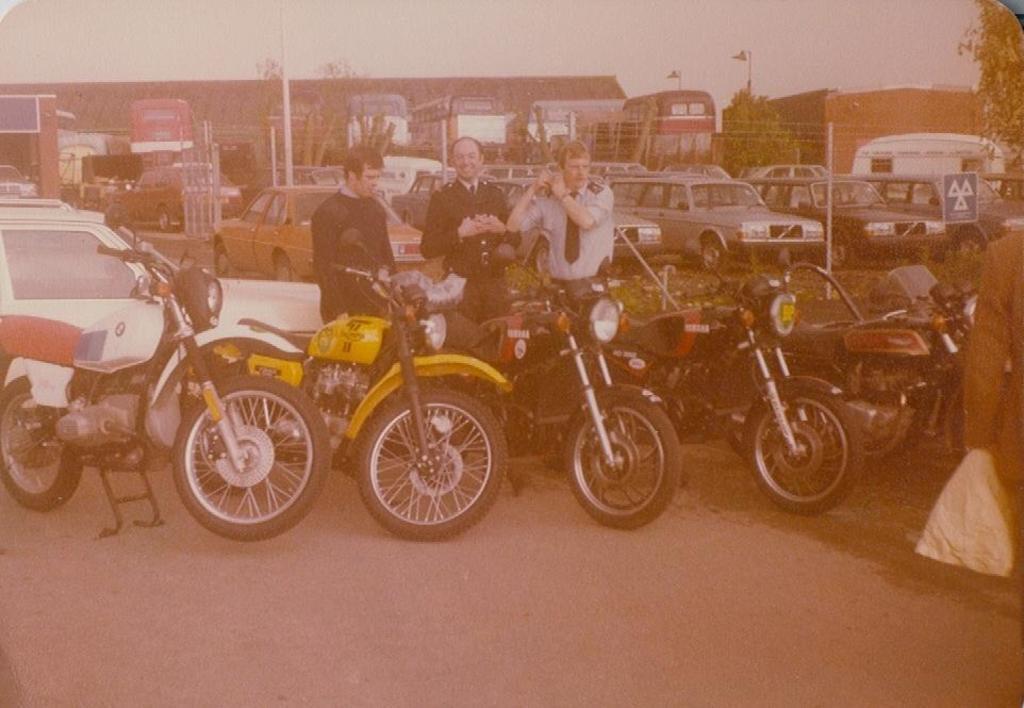Please provide a concise description of this image. In this image we can see motorcycles and other vehicles. There are few people standing. In the back there are trees. Also there are buildings. And there is sky. 